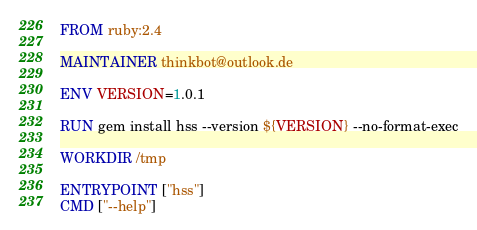Convert code to text. <code><loc_0><loc_0><loc_500><loc_500><_Dockerfile_>FROM ruby:2.4

MAINTAINER thinkbot@outlook.de

ENV VERSION=1.0.1

RUN gem install hss --version ${VERSION} --no-format-exec

WORKDIR /tmp

ENTRYPOINT ["hss"]
CMD ["--help"]
</code> 